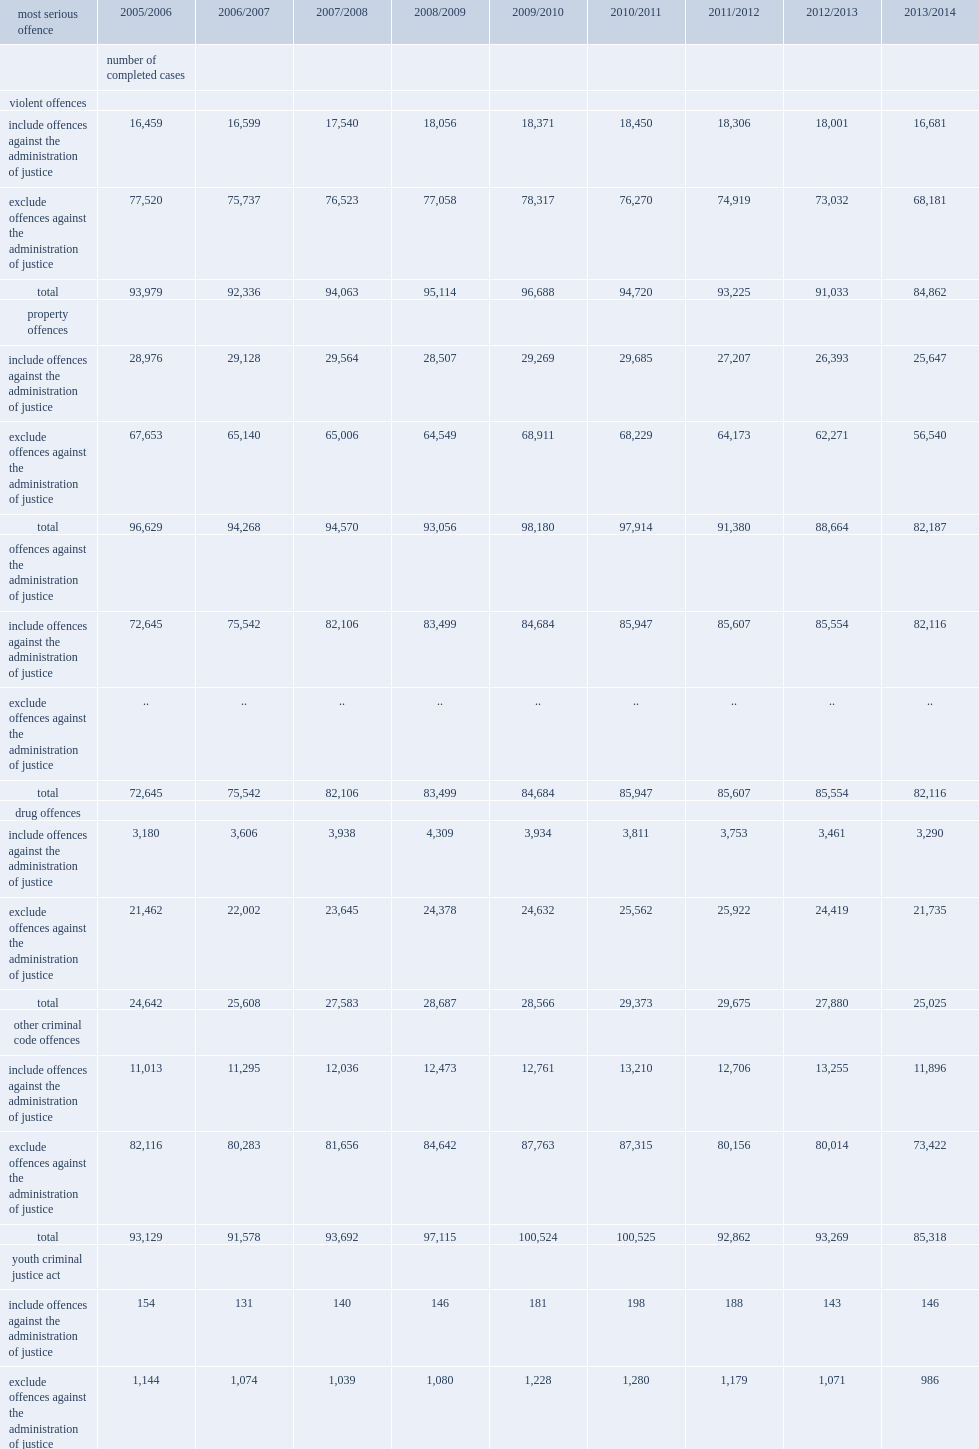In 2013/2014, what is the percentage of cases related to violent offences included charges for offences against the administration of justice? 0.196566. What is the percentage of cases where other criminal code charges such as those related to weapons, prostitution, and impaired driving were the mso include offences against the administration of justice in 2013/2014? 0.139431. What is the percentage of drug-related cases included offences against the administration of justice in 2013/2014? 0.131469. Parse the full table. {'header': ['most serious offence', '2005/2006', '2006/2007', '2007/2008', '2008/2009', '2009/2010', '2010/2011', '2011/2012', '2012/2013', '2013/2014'], 'rows': [['', 'number of completed cases', '', '', '', '', '', '', '', ''], ['violent offences', '', '', '', '', '', '', '', '', ''], ['include offences against the administration of justice', '16,459', '16,599', '17,540', '18,056', '18,371', '18,450', '18,306', '18,001', '16,681'], ['exclude offences against the administration of justice', '77,520', '75,737', '76,523', '77,058', '78,317', '76,270', '74,919', '73,032', '68,181'], ['total', '93,979', '92,336', '94,063', '95,114', '96,688', '94,720', '93,225', '91,033', '84,862'], ['property offences', '', '', '', '', '', '', '', '', ''], ['include offences against the administration of justice', '28,976', '29,128', '29,564', '28,507', '29,269', '29,685', '27,207', '26,393', '25,647'], ['exclude offences against the administration of justice', '67,653', '65,140', '65,006', '64,549', '68,911', '68,229', '64,173', '62,271', '56,540'], ['total', '96,629', '94,268', '94,570', '93,056', '98,180', '97,914', '91,380', '88,664', '82,187'], ['offences against the administration of justice', '', '', '', '', '', '', '', '', ''], ['include offences against the administration of justice', '72,645', '75,542', '82,106', '83,499', '84,684', '85,947', '85,607', '85,554', '82,116'], ['exclude offences against the administration of justice', '..', '..', '..', '..', '..', '..', '..', '..', '..'], ['total', '72,645', '75,542', '82,106', '83,499', '84,684', '85,947', '85,607', '85,554', '82,116'], ['drug offences', '', '', '', '', '', '', '', '', ''], ['include offences against the administration of justice', '3,180', '3,606', '3,938', '4,309', '3,934', '3,811', '3,753', '3,461', '3,290'], ['exclude offences against the administration of justice', '21,462', '22,002', '23,645', '24,378', '24,632', '25,562', '25,922', '24,419', '21,735'], ['total', '24,642', '25,608', '27,583', '28,687', '28,566', '29,373', '29,675', '27,880', '25,025'], ['other criminal code offences', '', '', '', '', '', '', '', '', ''], ['include offences against the administration of justice', '11,013', '11,295', '12,036', '12,473', '12,761', '13,210', '12,706', '13,255', '11,896'], ['exclude offences against the administration of justice', '82,116', '80,283', '81,656', '84,642', '87,763', '87,315', '80,156', '80,014', '73,422'], ['total', '93,129', '91,578', '93,692', '97,115', '100,524', '100,525', '92,862', '93,269', '85,318'], ['youth criminal justice act', '', '', '', '', '', '', '', '', ''], ['include offences against the administration of justice', '154', '131', '140', '146', '181', '198', '188', '143', '146'], ['exclude offences against the administration of justice', '1,144', '1,074', '1,039', '1,080', '1,228', '1,280', '1,179', '1,071', '986'], ['total', '1,298', '1,205', '1,179', '1,226', '1,409', '1,478', '1,367', '1,214', '1,132'], ['total offences', '', '', '', '', '', '', '', '', ''], ['include offences against the administration of justice', '132,427', '136,301', '145,324', '146,990', '149,200', '151,301', '147,767', '146,807', '139,776'], ['exclude offences against the administration of justice', '249,895', '244,236', '247,869', '251,707', '260,851', '258,656', '246,349', '240,807', '220,864'], ['total', '382,322', '380,537', '393,193', '398,697', '410,051', '409,957', '394,116', '387,614', '360,640']]} 